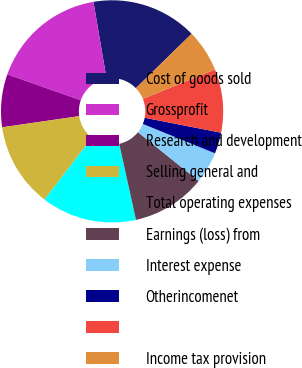Convert chart. <chart><loc_0><loc_0><loc_500><loc_500><pie_chart><fcel>Cost of goods sold<fcel>Grossprofit<fcel>Research and development<fcel>Selling general and<fcel>Total operating expenses<fcel>Earnings (loss) from<fcel>Interest expense<fcel>Otherincomenet<fcel>Unnamed: 8<fcel>Income tax provision<nl><fcel>15.38%<fcel>16.92%<fcel>7.69%<fcel>12.31%<fcel>13.85%<fcel>10.77%<fcel>4.62%<fcel>3.08%<fcel>9.23%<fcel>6.15%<nl></chart> 